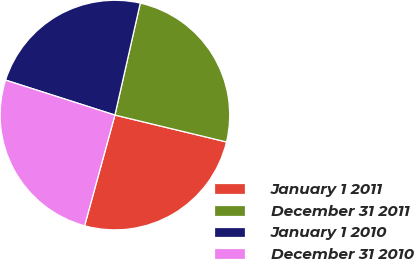<chart> <loc_0><loc_0><loc_500><loc_500><pie_chart><fcel>January 1 2011<fcel>December 31 2011<fcel>January 1 2010<fcel>December 31 2010<nl><fcel>25.49%<fcel>25.22%<fcel>23.62%<fcel>25.67%<nl></chart> 